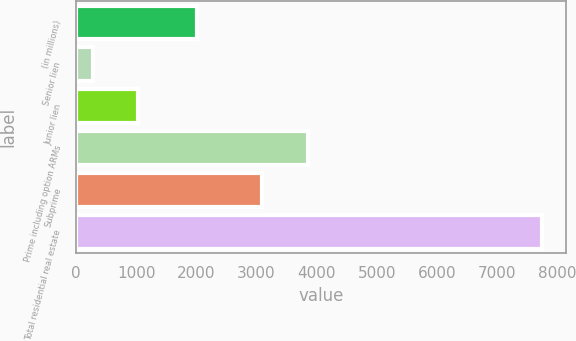Convert chart to OTSL. <chart><loc_0><loc_0><loc_500><loc_500><bar_chart><fcel>(in millions)<fcel>Senior lien<fcel>Junior lien<fcel>Prime including option ARMs<fcel>Subprime<fcel>Total residential real estate<nl><fcel>2011<fcel>287<fcel>1033.3<fcel>3859<fcel>3083<fcel>7750<nl></chart> 